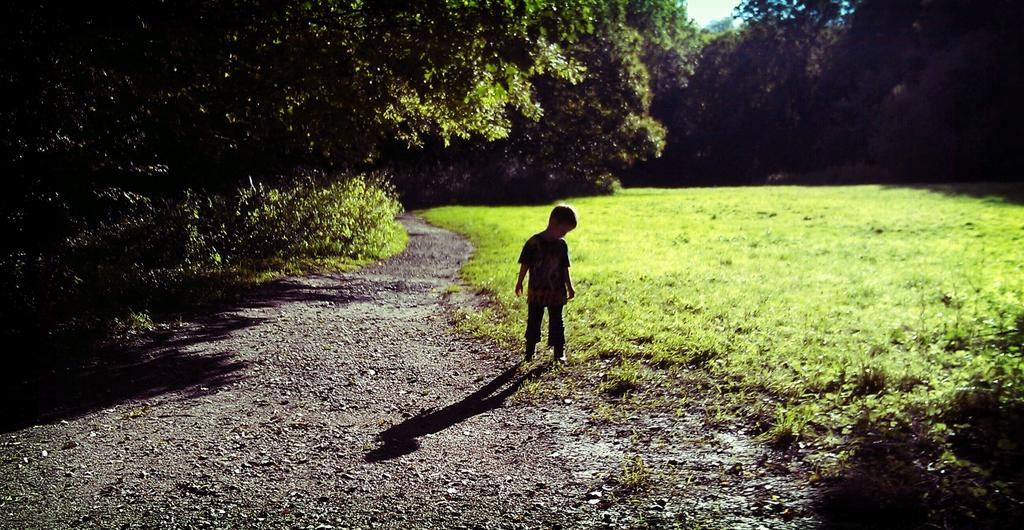What is the main subject of the picture? The main subject of the picture is a kid standing. What type of ground is visible at the bottom of the image? There is grass at the bottom of the image. What can be seen in the background of the picture? Trees are visible in the background of the image. What type of string is the kid holding in the image? There is no string present in the image. Can you see any pickles in the grass at the bottom of the image? There are no pickles visible in the image; only grass is present. 